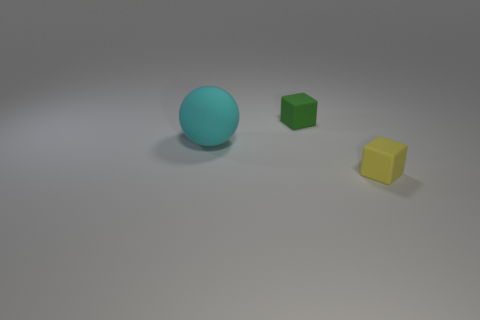Add 1 red rubber balls. How many objects exist? 4 Subtract all spheres. How many objects are left? 2 Subtract all large matte blocks. Subtract all yellow blocks. How many objects are left? 2 Add 2 small green objects. How many small green objects are left? 3 Add 1 tiny yellow rubber cubes. How many tiny yellow rubber cubes exist? 2 Subtract 0 purple cubes. How many objects are left? 3 